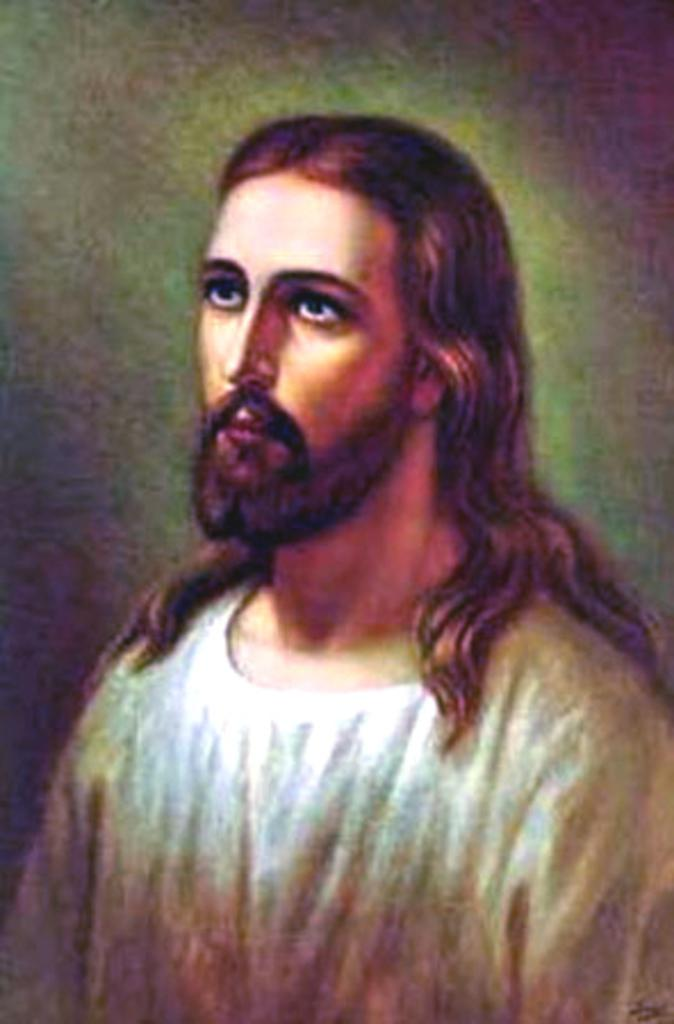What is the main subject of the image? The main subject of the image is a painting. What does the painting depict? The painting depicts a person. In which direction is the person in the painting looking? The person in the painting is looking to the left side. What is the person in the painting wearing? The person in the painting is wearing a white color dress. What type of sweater is the person wearing in the painting? The person in the painting is not wearing a sweater; they are wearing a white color dress. 